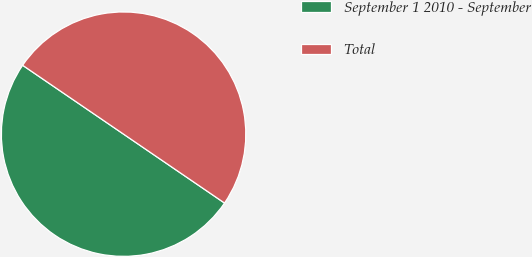Convert chart to OTSL. <chart><loc_0><loc_0><loc_500><loc_500><pie_chart><fcel>September 1 2010 - September<fcel>Total<nl><fcel>50.0%<fcel>50.0%<nl></chart> 